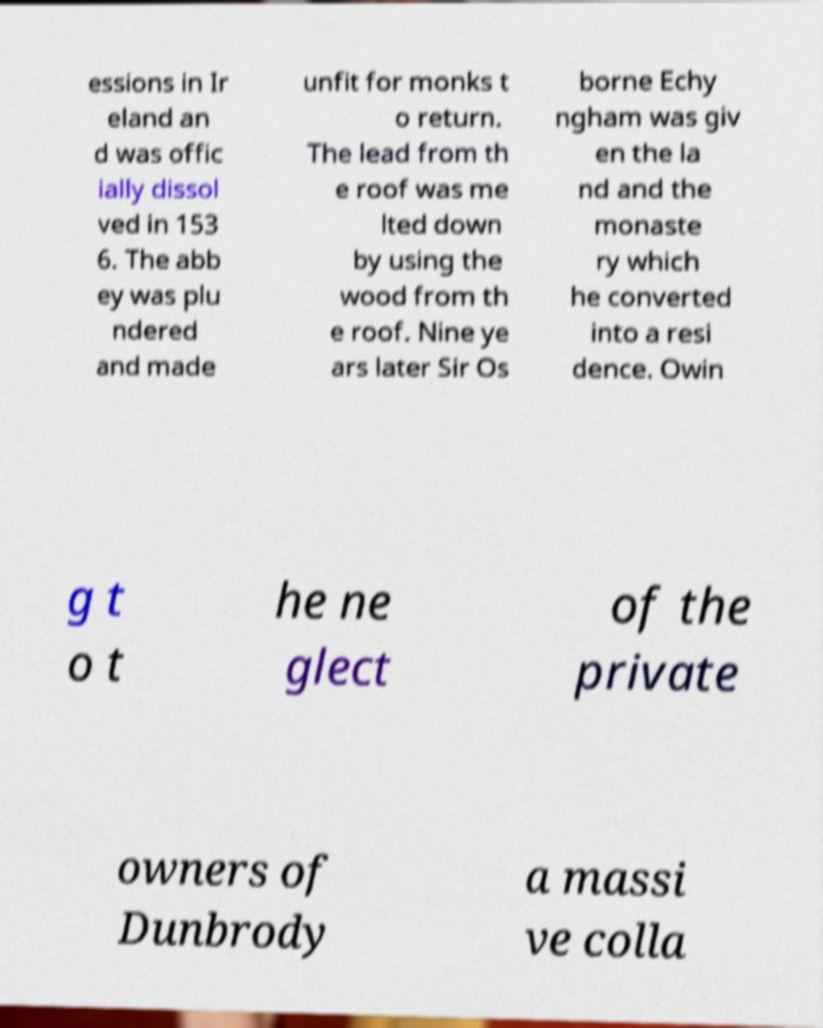For documentation purposes, I need the text within this image transcribed. Could you provide that? essions in Ir eland an d was offic ially dissol ved in 153 6. The abb ey was plu ndered and made unfit for monks t o return. The lead from th e roof was me lted down by using the wood from th e roof. Nine ye ars later Sir Os borne Echy ngham was giv en the la nd and the monaste ry which he converted into a resi dence. Owin g t o t he ne glect of the private owners of Dunbrody a massi ve colla 